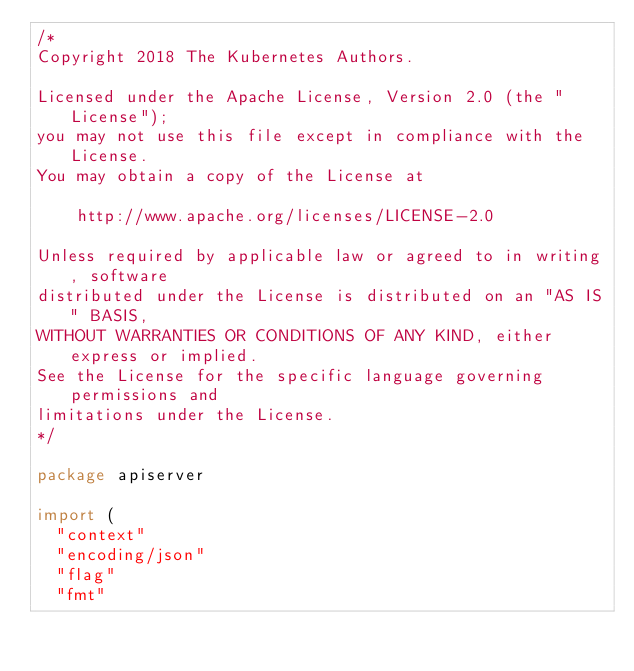Convert code to text. <code><loc_0><loc_0><loc_500><loc_500><_Go_>/*
Copyright 2018 The Kubernetes Authors.

Licensed under the Apache License, Version 2.0 (the "License");
you may not use this file except in compliance with the License.
You may obtain a copy of the License at

    http://www.apache.org/licenses/LICENSE-2.0

Unless required by applicable law or agreed to in writing, software
distributed under the License is distributed on an "AS IS" BASIS,
WITHOUT WARRANTIES OR CONDITIONS OF ANY KIND, either express or implied.
See the License for the specific language governing permissions and
limitations under the License.
*/

package apiserver

import (
	"context"
	"encoding/json"
	"flag"
	"fmt"</code> 